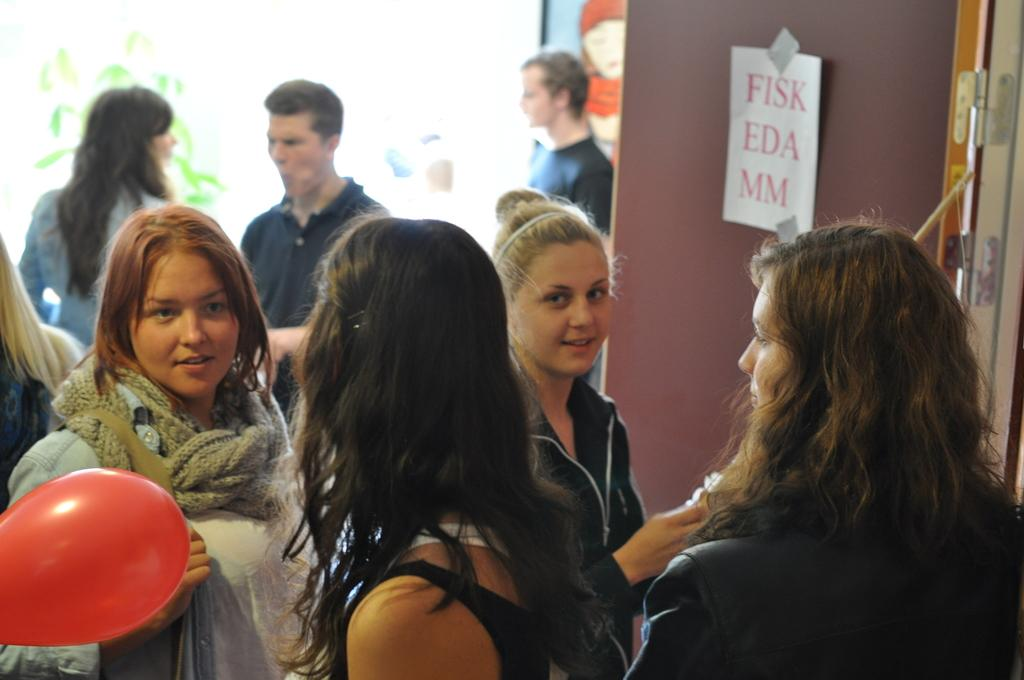Who or what can be seen in the image? There are people in the image. What color is the balloon that is visible in the image? There is a red balloon in the image. What is on the door in the image? There is a poster on a door in the image. Can you describe the background of the image? The background of the image is blurry. What type of lumber is being used to construct the acoustics in the image? There is no mention of lumber or acoustics in the image; it features people, a red balloon, a poster on a door, and a blurry background. 